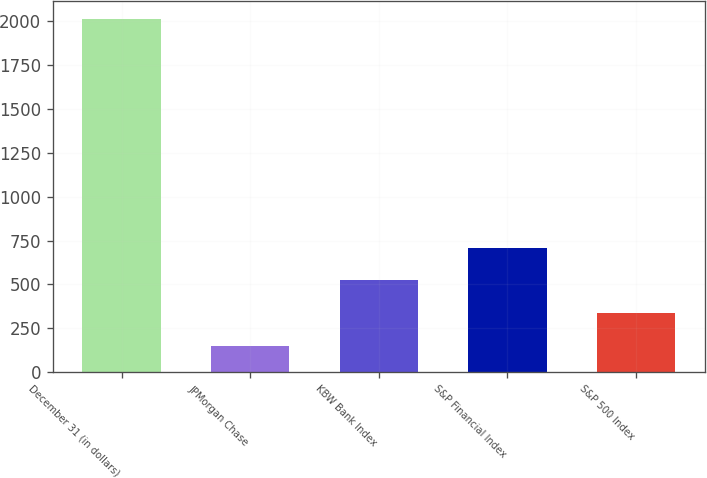Convert chart to OTSL. <chart><loc_0><loc_0><loc_500><loc_500><bar_chart><fcel>December 31 (in dollars)<fcel>JPMorgan Chase<fcel>KBW Bank Index<fcel>S&P Financial Index<fcel>S&P 500 Index<nl><fcel>2014<fcel>150.22<fcel>522.98<fcel>709.36<fcel>336.6<nl></chart> 